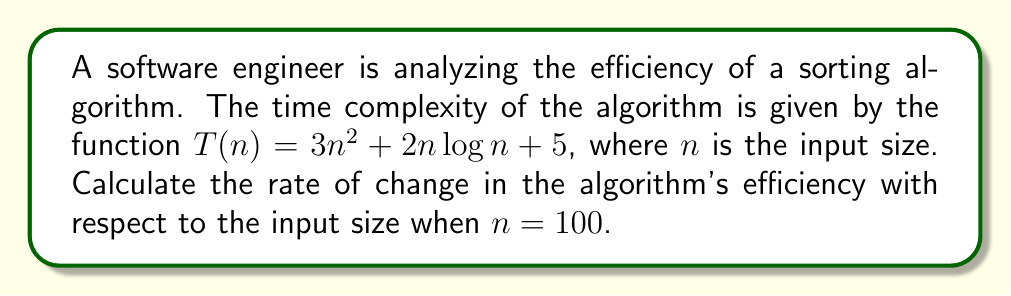Teach me how to tackle this problem. To find the rate of change in the algorithm's efficiency with respect to the input size, we need to calculate the derivative of the time complexity function $T(n)$ and evaluate it at $n = 100$. Let's break this down step-by-step:

1. Given time complexity function: $T(n) = 3n^2 + 2n\log n + 5$

2. Calculate the derivative $T'(n)$:
   a. Derivative of $3n^2$: $\frac{d}{dn}(3n^2) = 6n$
   b. Derivative of $2n\log n$: $\frac{d}{dn}(2n\log n) = 2\log n + 2$
   c. Derivative of 5: $\frac{d}{dn}(5) = 0$

3. Combine the derivatives:
   $T'(n) = 6n + 2\log n + 2$

4. Evaluate $T'(n)$ at $n = 100$:
   $T'(100) = 6(100) + 2\log(100) + 2$
   $= 600 + 2\log(100) + 2$
   $= 600 + 2(4.605) + 2$ (using natural logarithm)
   $= 600 + 9.21 + 2$
   $= 611.21$

The rate of change in the algorithm's efficiency when $n = 100$ is approximately 611.21 time units per input size unit.
Answer: $611.21$ 